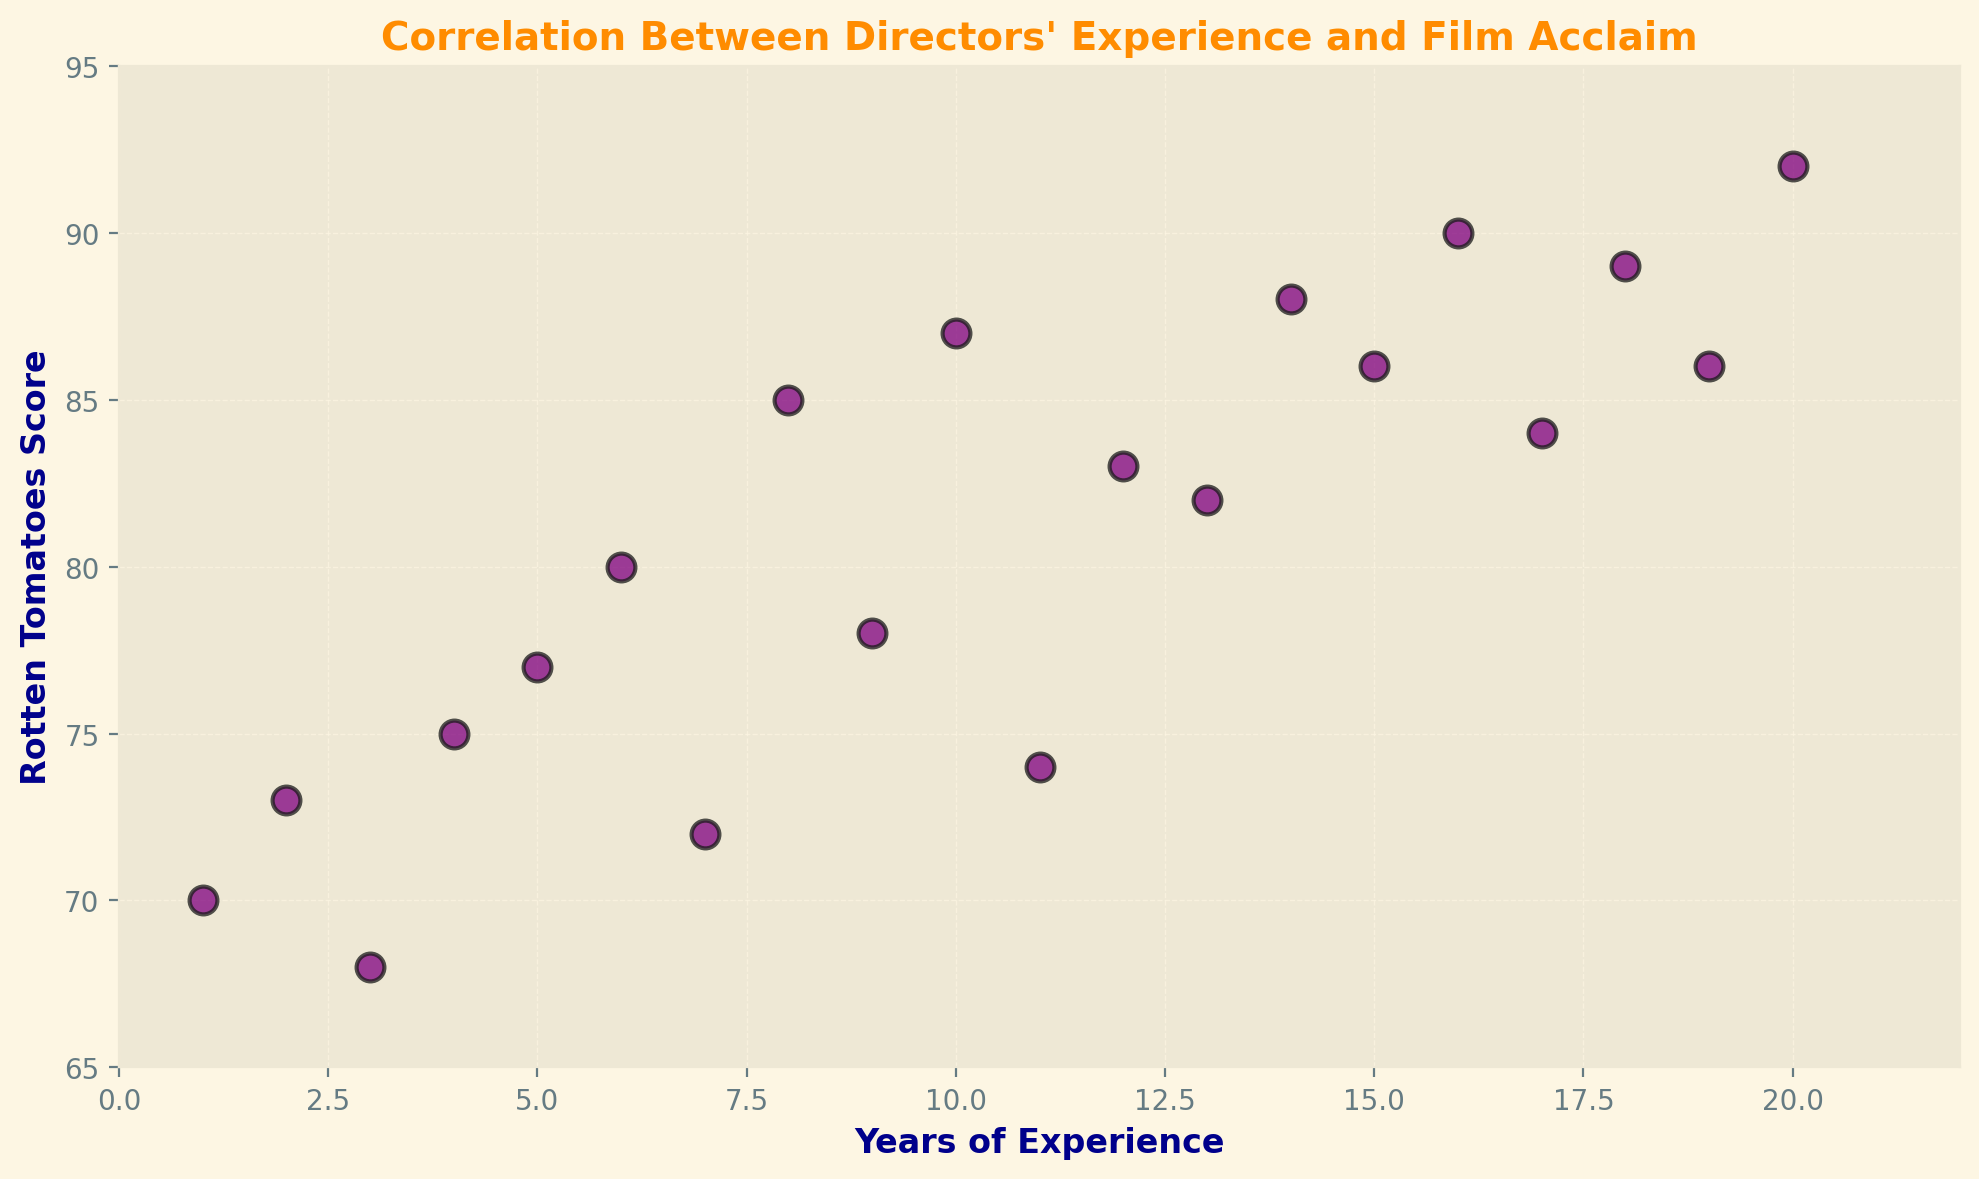What is the trend depicted by the scatter plot? Each data point increases diagonally from the bottom left to the upper right of the scatter plot, indicating a positive correlation between years of experience and Rotten Tomatoes scores. Directors with more years of experience generally achieve higher critical acclaim for their films.
Answer: Positive correlation Which director has the lowest Rotten Tomatoes score and how many years of experience do they have? The director with the lowest Rotten Tomatoes score is highlighted by the lowest point on the scatter plot. The point is at a Rotten Tomatoes score of 68, which corresponds to 3 years of experience.
Answer: 3 years of experience Is there a director with 10 years of experience, and what is their Rotten Tomatoes score? By locating the data point for 10 years of experience on the x-axis and seeing its corresponding y-value, we see that the point is at a Rotten Tomatoes score of 87.
Answer: 87 How does the average Rotten Tomatoes score change after 10 years of experience compared to before? To solve this, calculate the average Rotten Tomatoes score for both segments (before and after 10 years) and compare them. The average score before 10 years is (70+73+68+75+77+80+72+85+78+87)/10 = 76.5. The average score after 10 years is (74+83+82+88+86+90+84+89+86+92)/10 = 85.4. Therefore, the average score increases by 85.4 - 76.5 = 8.9.
Answer: 8.9 Which director(s) have a Rotten Tomatoes score of exactly 86, and how many years of experience do they have? By locating the data points on the y-axis that correspond to a Rotten Tomatoes score of 86 and checking their x-axis values, we find that there are two points: one at 15 years of experience and another at 19 years of experience.
Answer: 15 and 19 years of experience What is the visual style used for the scatter plot points? The scatter plot points are depicted using circular markers with a purple color, black edge color, and medium transparency. They have moderately sized markers making them easily visible on the plot.
Answer: Purple circular markers with black edges What is the range of Rotten Tomatoes scores depicted on the scatter plot? The lowest Rotten Tomatoes score is 68, and the highest score is 92. This range is observed from the y-axis values of the points in the scatter plot.
Answer: 68 to 92 Based on the scatter plot, what is the expected Rotten Tomatoes score for a director with 5 years of experience? By locating the point at 5 years of experience on the x-axis and observing its corresponding y-value, we find the Rotten Tomatoes score is 77.
Answer: 77 Are there any directors with exactly 8 years of experience, and what is their Rotten Tomatoes score? By finding the point that corresponds to 8 years of experience on the x-axis, we observe its y-value. The Rotten Tomatoes score for a director with 8 years of experience is 85.
Answer: 85 Is there any visual indication of an outlier in the scatter plot? No points in the scatter plot are visibly far removed from the trend that indicates a positive correlation, suggesting there are no outliers. All points appear to follow the general increasing trend.
Answer: No 